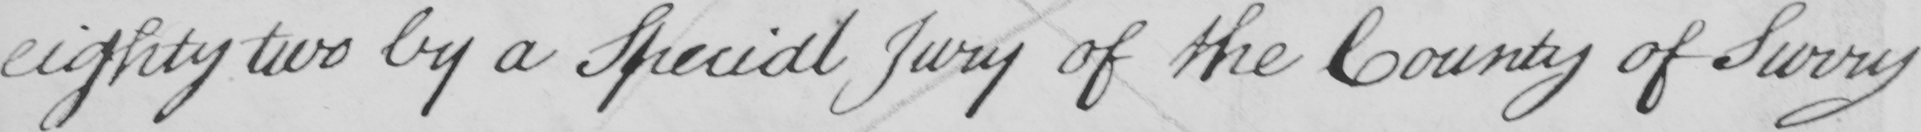What does this handwritten line say? eighty two by a Special Jury of the County of Surry 